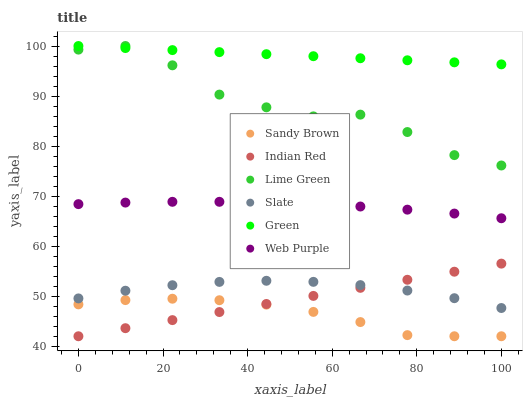Does Sandy Brown have the minimum area under the curve?
Answer yes or no. Yes. Does Green have the maximum area under the curve?
Answer yes or no. Yes. Does Slate have the minimum area under the curve?
Answer yes or no. No. Does Slate have the maximum area under the curve?
Answer yes or no. No. Is Indian Red the smoothest?
Answer yes or no. Yes. Is Lime Green the roughest?
Answer yes or no. Yes. Is Slate the smoothest?
Answer yes or no. No. Is Slate the roughest?
Answer yes or no. No. Does Sandy Brown have the lowest value?
Answer yes or no. Yes. Does Slate have the lowest value?
Answer yes or no. No. Does Lime Green have the highest value?
Answer yes or no. Yes. Does Slate have the highest value?
Answer yes or no. No. Is Indian Red less than Lime Green?
Answer yes or no. Yes. Is Green greater than Web Purple?
Answer yes or no. Yes. Does Sandy Brown intersect Indian Red?
Answer yes or no. Yes. Is Sandy Brown less than Indian Red?
Answer yes or no. No. Is Sandy Brown greater than Indian Red?
Answer yes or no. No. Does Indian Red intersect Lime Green?
Answer yes or no. No. 